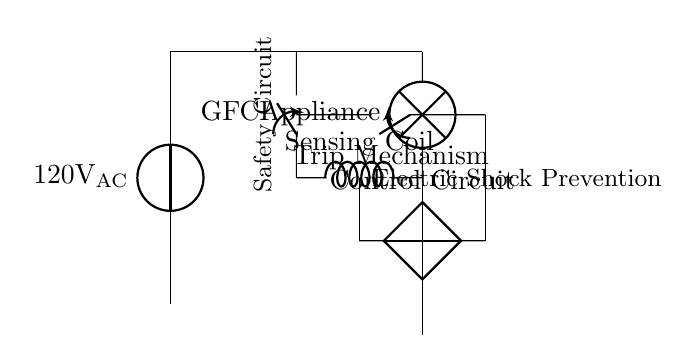What is the voltage source used in this circuit? The circuit diagram indicates a voltage source labeled as 120 volts AC, which is a standard voltage for household appliances in many regions.
Answer: 120 volts AC What component is responsible for detecting ground faults? The component identified as GFCI in the circuit is specifically designed to detect any ground faults by monitoring the current flowing through the circuit and trip if a fault is detected.
Answer: GFCI What is the purpose of the sensing coil in this circuit? The sensing coil is used to monitor the current flowing through the circuit and can help in detecting irregularities that may indicate potential ground faults or shorts, activating the safety mechanism.
Answer: Monitor current What is the function of the trip mechanism in this circuit? The trip mechanism acts to break the circuit when a ground fault is detected, ensuring that electricity is cut off to prevent electric shock hazards to users.
Answer: Breaks the circuit How does the control circuit relate to the overall safety function? The control circuit receives signals from the sensing coil and commands the trip mechanism to activate, ensuring immediate action is taken to prevent electric shock when a fault is identified.
Answer: Activates trip mechanism What does the ground connection in this circuit signify? The ground connection provides a safe path for electrical current to return to the ground, preventing shock hazards by ensuring that if a fault occurs, the excess current has a safe route to dissipate.
Answer: Safe path 